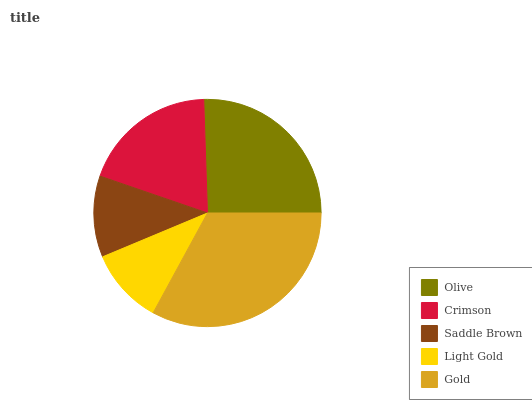Is Light Gold the minimum?
Answer yes or no. Yes. Is Gold the maximum?
Answer yes or no. Yes. Is Crimson the minimum?
Answer yes or no. No. Is Crimson the maximum?
Answer yes or no. No. Is Olive greater than Crimson?
Answer yes or no. Yes. Is Crimson less than Olive?
Answer yes or no. Yes. Is Crimson greater than Olive?
Answer yes or no. No. Is Olive less than Crimson?
Answer yes or no. No. Is Crimson the high median?
Answer yes or no. Yes. Is Crimson the low median?
Answer yes or no. Yes. Is Olive the high median?
Answer yes or no. No. Is Saddle Brown the low median?
Answer yes or no. No. 